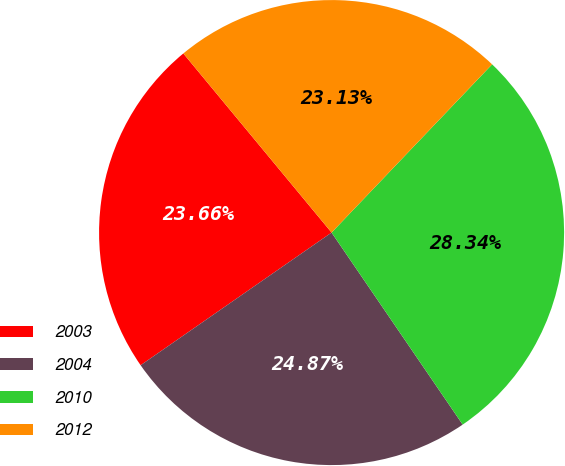Convert chart to OTSL. <chart><loc_0><loc_0><loc_500><loc_500><pie_chart><fcel>2003<fcel>2004<fcel>2010<fcel>2012<nl><fcel>23.66%<fcel>24.87%<fcel>28.34%<fcel>23.13%<nl></chart> 